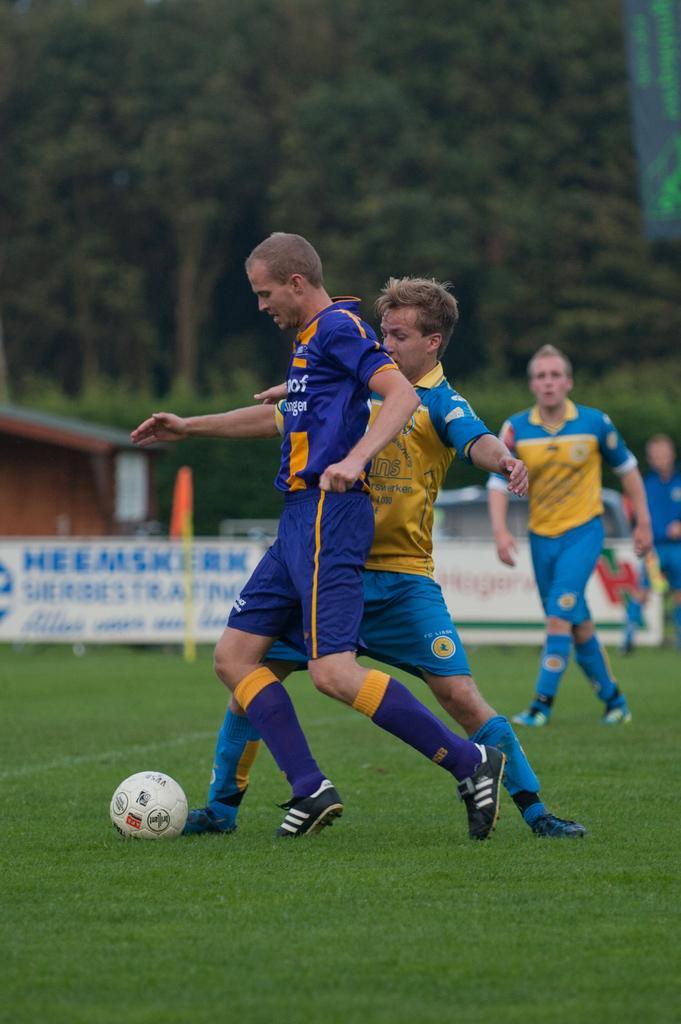How would you summarize this image in a sentence or two? This picture is taken outside on a sunny day. Few persons are playing football on grassy land. Person wearing a blue and yellow shirt is wearing socks and shoes is walking. There is a ball on ground. At the back side there is a banner, behind there is a house. Background there are few trees. 